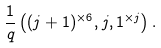Convert formula to latex. <formula><loc_0><loc_0><loc_500><loc_500>\frac { 1 } { q } \left ( ( j + 1 ) ^ { \times 6 } , j , 1 ^ { \times j } \right ) .</formula> 